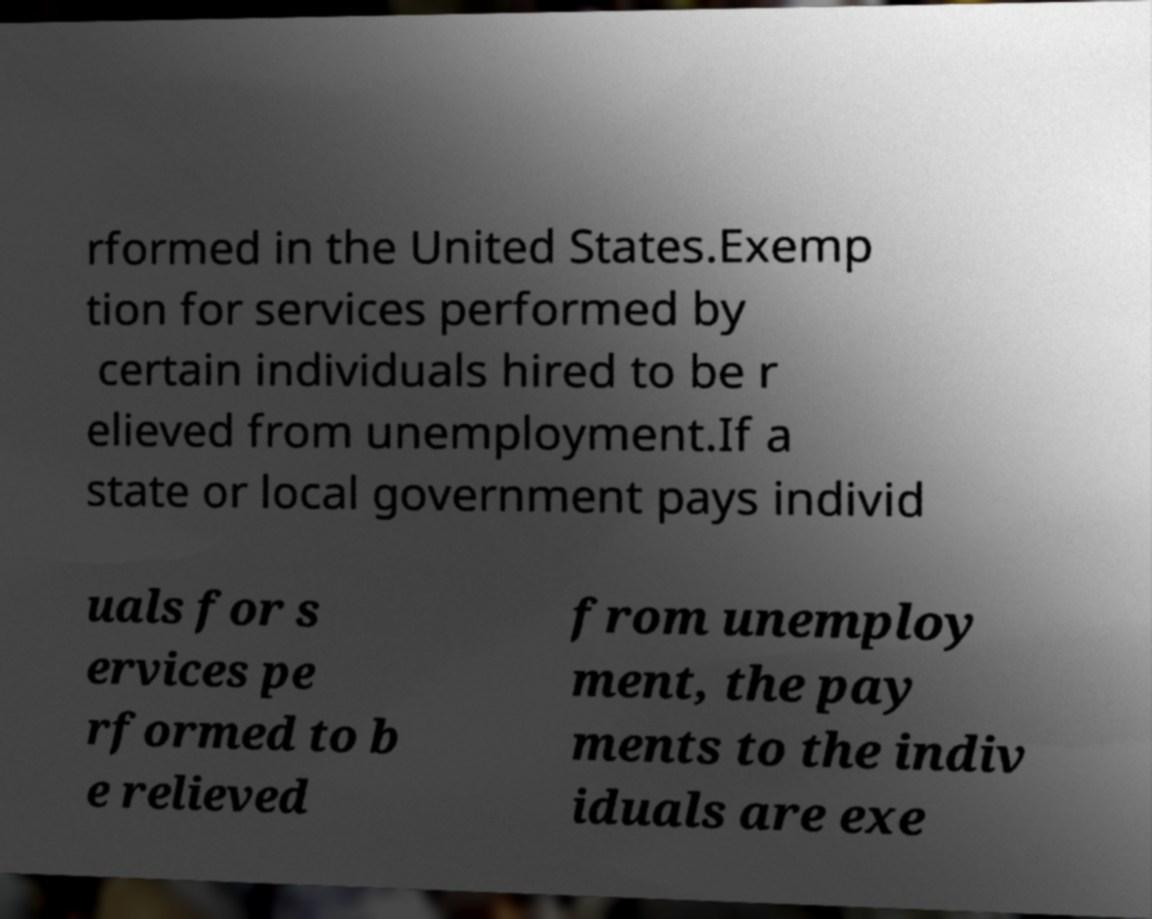Please identify and transcribe the text found in this image. rformed in the United States.Exemp tion for services performed by certain individuals hired to be r elieved from unemployment.If a state or local government pays individ uals for s ervices pe rformed to b e relieved from unemploy ment, the pay ments to the indiv iduals are exe 